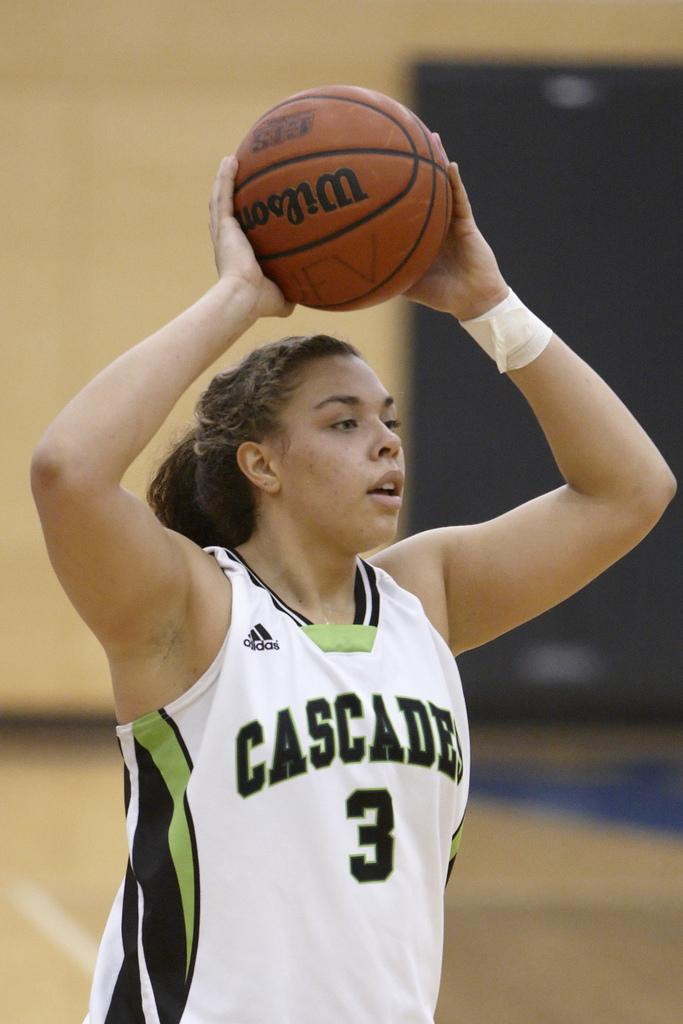Provide a one-sentence caption for the provided image. Basketball player for cascade is holding a basketball. 